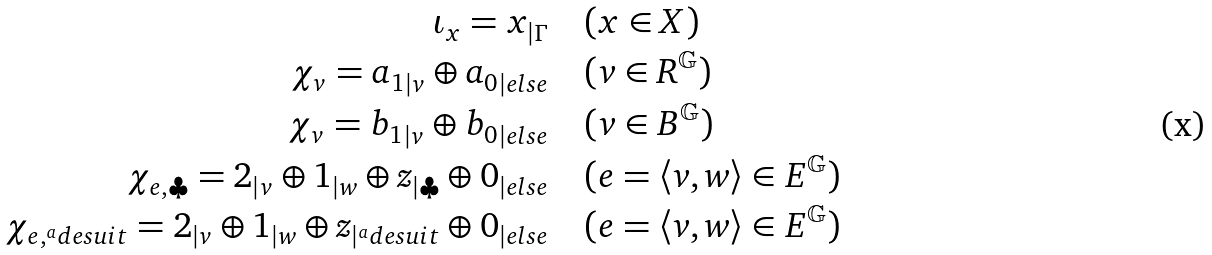Convert formula to latex. <formula><loc_0><loc_0><loc_500><loc_500>\iota _ { x } = x _ { | \Gamma } & \quad ( x \in X ) \\ \chi _ { v } = { a _ { 1 } } _ { | v } \oplus { a _ { 0 } } _ { | e l s e } & \quad ( v \in R ^ { \mathbb { G } } ) \\ \chi _ { v } = { b _ { 1 } } _ { | v } \oplus { b _ { 0 } } _ { | e l s e } & \quad ( v \in B ^ { \mathbb { G } } ) \\ \chi _ { e , \clubsuit } = 2 _ { | v } \oplus 1 _ { | w } \oplus z _ { | \clubsuit } \oplus 0 _ { | e l s e } & \quad ( e = \langle v , w \rangle \in E ^ { \mathbb { G } } ) \\ \chi _ { e , ^ { a } d e s u i t } = 2 _ { | v } \oplus 1 _ { | w } \oplus z _ { | ^ { a } d e s u i t } \oplus 0 _ { | e l s e } & \quad ( e = \langle v , w \rangle \in E ^ { \mathbb { G } } )</formula> 